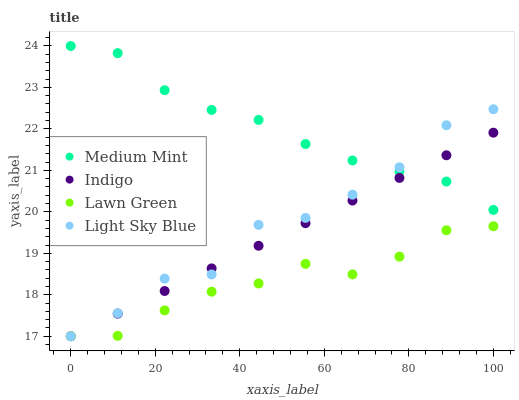Does Lawn Green have the minimum area under the curve?
Answer yes or no. Yes. Does Medium Mint have the maximum area under the curve?
Answer yes or no. Yes. Does Light Sky Blue have the minimum area under the curve?
Answer yes or no. No. Does Light Sky Blue have the maximum area under the curve?
Answer yes or no. No. Is Indigo the smoothest?
Answer yes or no. Yes. Is Light Sky Blue the roughest?
Answer yes or no. Yes. Is Lawn Green the smoothest?
Answer yes or no. No. Is Lawn Green the roughest?
Answer yes or no. No. Does Lawn Green have the lowest value?
Answer yes or no. Yes. Does Medium Mint have the highest value?
Answer yes or no. Yes. Does Light Sky Blue have the highest value?
Answer yes or no. No. Is Lawn Green less than Medium Mint?
Answer yes or no. Yes. Is Medium Mint greater than Lawn Green?
Answer yes or no. Yes. Does Light Sky Blue intersect Medium Mint?
Answer yes or no. Yes. Is Light Sky Blue less than Medium Mint?
Answer yes or no. No. Is Light Sky Blue greater than Medium Mint?
Answer yes or no. No. Does Lawn Green intersect Medium Mint?
Answer yes or no. No. 